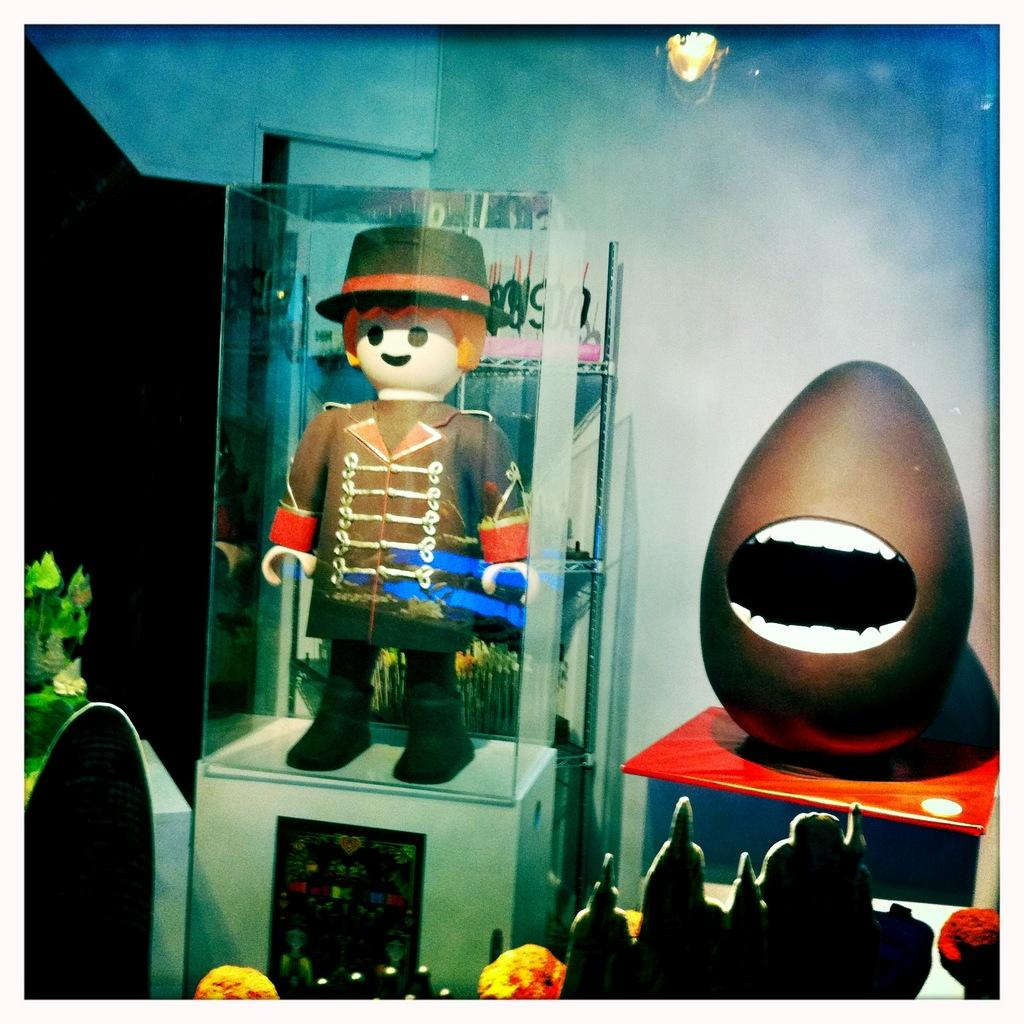What is the main subject of the image? There is a depiction of a man in the image. What else can be seen in the image besides the man? There are toys and objects in the image. Are there any light sources visible in the image? Yes, the image includes lights. What type of background is present in the image? There is a wall in the image. Can you tell me how many times the man in the image smiled? There is no indication of the man's facial expression in the image, so it cannot be determined if he smiled or not. 